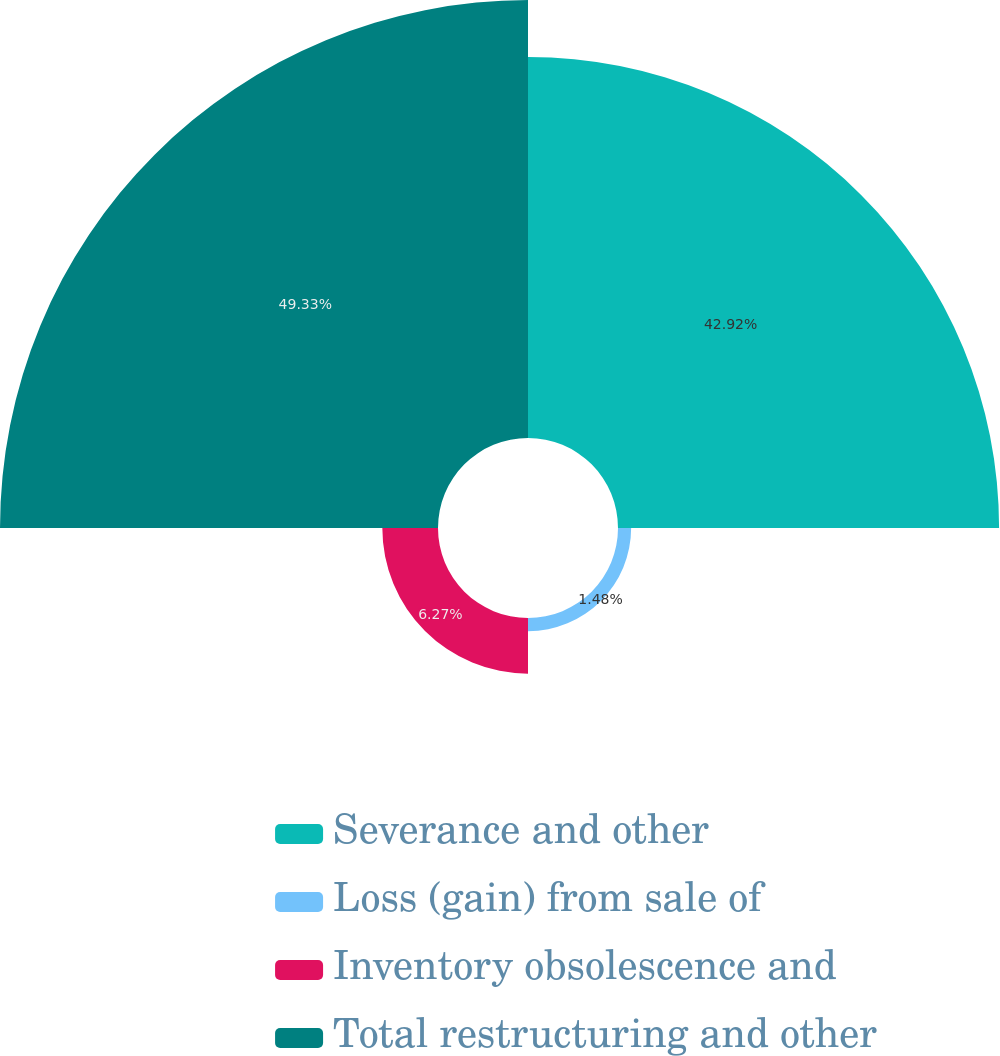<chart> <loc_0><loc_0><loc_500><loc_500><pie_chart><fcel>Severance and other<fcel>Loss (gain) from sale of<fcel>Inventory obsolescence and<fcel>Total restructuring and other<nl><fcel>42.92%<fcel>1.48%<fcel>6.27%<fcel>49.33%<nl></chart> 